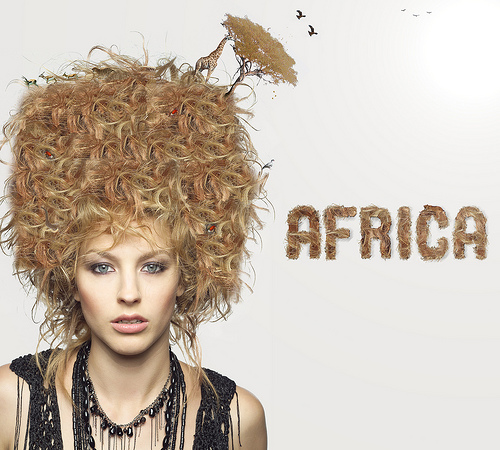<image>
Is there a curly hair behind the background poster? No. The curly hair is not behind the background poster. From this viewpoint, the curly hair appears to be positioned elsewhere in the scene. 